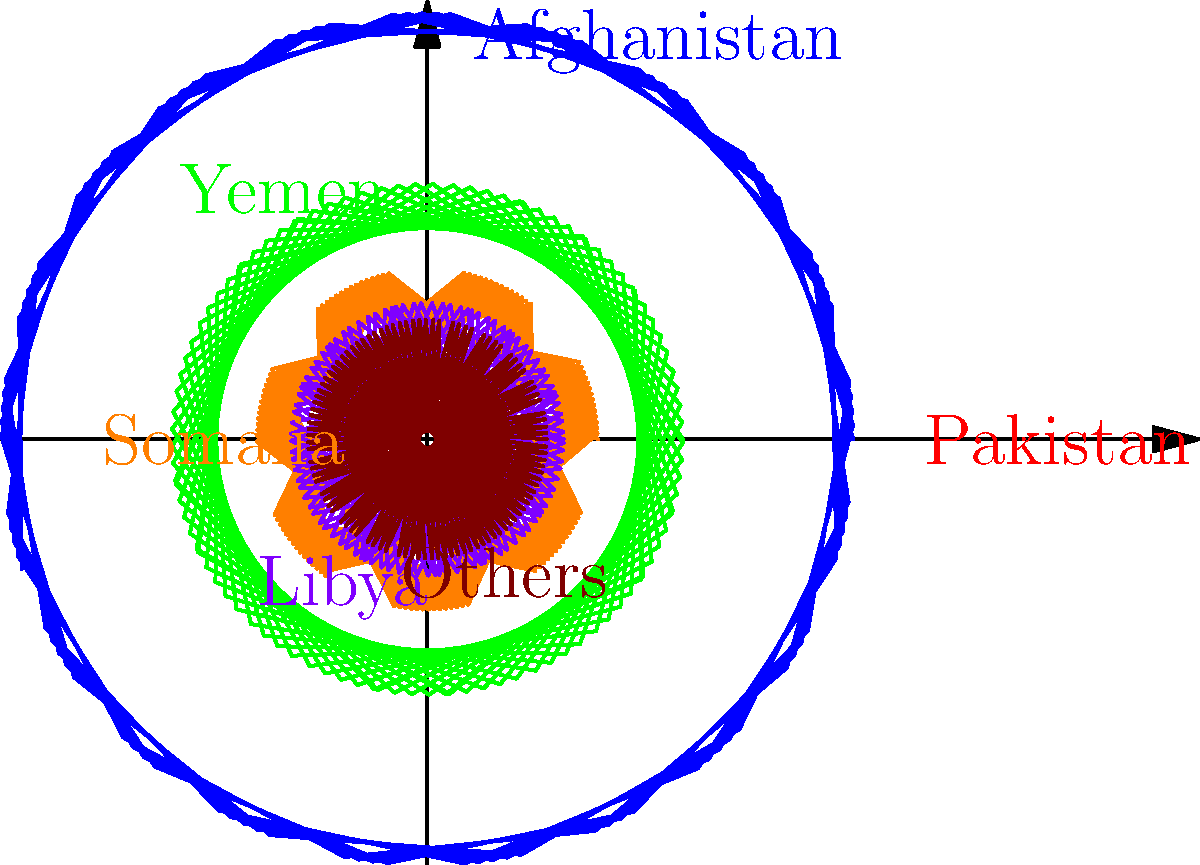Based on the polar coordinate graph representing the geographic distribution of drone strikes during Obama's presidency, which country was the primary target of these operations? To determine the primary target of drone strikes during Obama's presidency, we need to analyze the polar coordinate graph:

1. The graph shows six sectors, each representing a different geographic region.
2. The length of each sector indicates the relative number of drone strikes in that region.
3. The sectors are labeled with country names or "Others" for miscellaneous locations.
4. Examining the lengths of the sectors:
   - Pakistan has the longest sector, extending furthest from the center.
   - Afghanistan has the second-longest sector.
   - Yemen, Somalia, Libya, and Others have progressively shorter sectors.
5. The longest sector represents the highest number of drone strikes.

Therefore, based on this visual representation, Pakistan was the primary target of drone strikes during Obama's presidency, as it has the longest sector in the polar coordinate graph.
Answer: Pakistan 